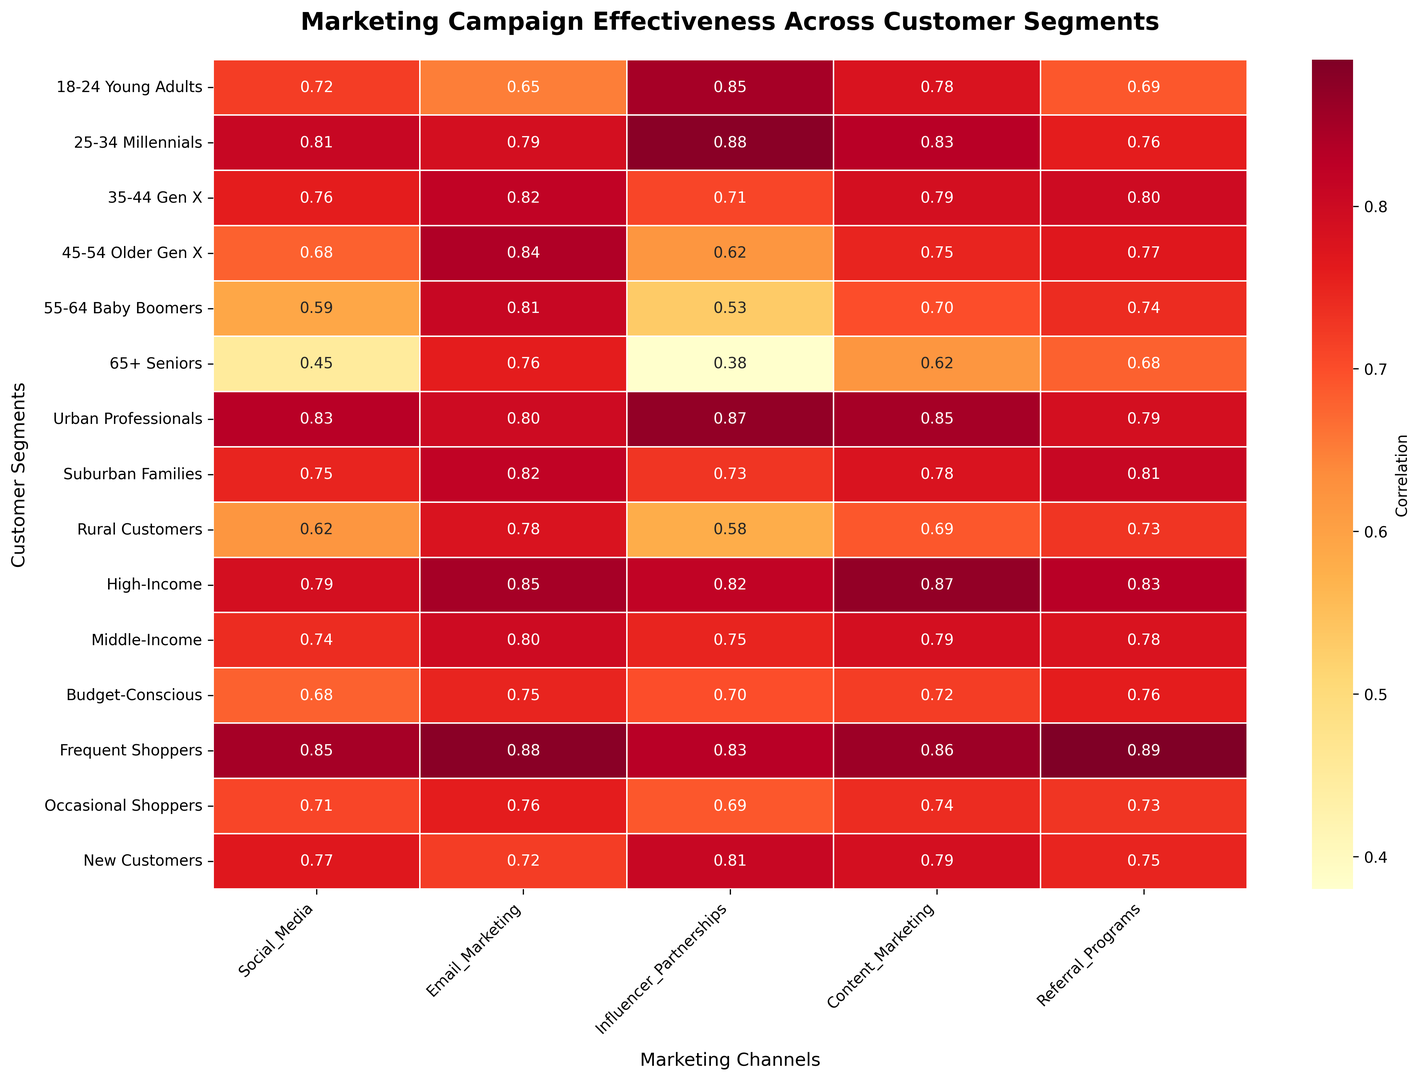Which customer segment has the highest correlation with Social Media campaigns? Look across the Social Media column and find the highest value. The highest correlation is 0.85 for Frequent Shoppers.
Answer: Frequent Shoppers How does the effectiveness of Email Marketing compare between Millennials and Baby Boomers? Compare the values in the Email Marketing column for Millennials (0.79) and Baby Boomers (0.81). Baby Boomers show a slightly higher correlation than Millennials.
Answer: Baby Boomers have higher effectiveness Which marketing channel shows the lowest retention with Seniors? Look across the Seniors row and find the lowest value. The lowest correlation is 0.38 for Influencer Partnerships.
Answer: Influencer Partnerships What is the average effectiveness of Social Media campaigns across all customer segments? Sum the correlations for Social Media across all segments and divide by the number of segments: (0.72 + 0.81 + 0.76 + 0.68 + 0.59 + 0.45 + 0.83 + 0.75 + 0.62 + 0.79 + 0.74 + 0.68 + 0.85 + 0.71 + 0.77)/15 ≈ 0.73
Answer: 0.73 Which customer segment responds better to Referral Programs compared to Social Media? Compare values in the Referral Programs and Social Media columns for each segment. Gen X (0.80 vs. 0.76), Older Gen X (0.77 vs. 0.68), Baby Boomers (0.74 vs. 0.59), and Seniors (0.68 vs. 0.45) show higher retention with Referral Programs.
Answer: Gen X, Older Gen X, Baby Boomers, Seniors What is the difference in Content Marketing effectiveness between High-Income and Budget-Conscious customers? Subtract the correlation value for Budget-Conscious (0.72) from High-Income (0.87): 0.87 - 0.72 = 0.15
Answer: 0.15 Which marketing campaign is most effective for New Customers? Look across the New Customers row and find the highest value. The highest correlation is 0.81 for Influencer Partnerships.
Answer: Influencer Partnerships Is the effectiveness of Influencer Partnerships higher or lower than Referral Programs for Occasional Shoppers? Compare the values in the Influencer Partnerships (0.69) and Referral Programs (0.73) columns for Occasional Shoppers. Referral Programs (0.73) have a higher value.
Answer: Lower What is the total correlation value for Email Marketing across all age-based segments (18-24, 25-34, 35-44, 45-54, 55-64, 65+)? Sum the correlations for Email Marketing across the age-based segments: 0.65 + 0.79 + 0.82 + 0.84 + 0.81 + 0.76 = 4.67
Answer: 4.67 Which customer segment has the widest range of effectiveness across all marketing channels? Calculate the range (max - min) for each segment and compare. For Frequent Shoppers: Max (0.89) - Min (0.83) = 0.06. Compare this with other segments to find the widest range. The widest range is for Seniors, with Max (0.76) - Min (0.38) = 0.38.
Answer: Seniors 